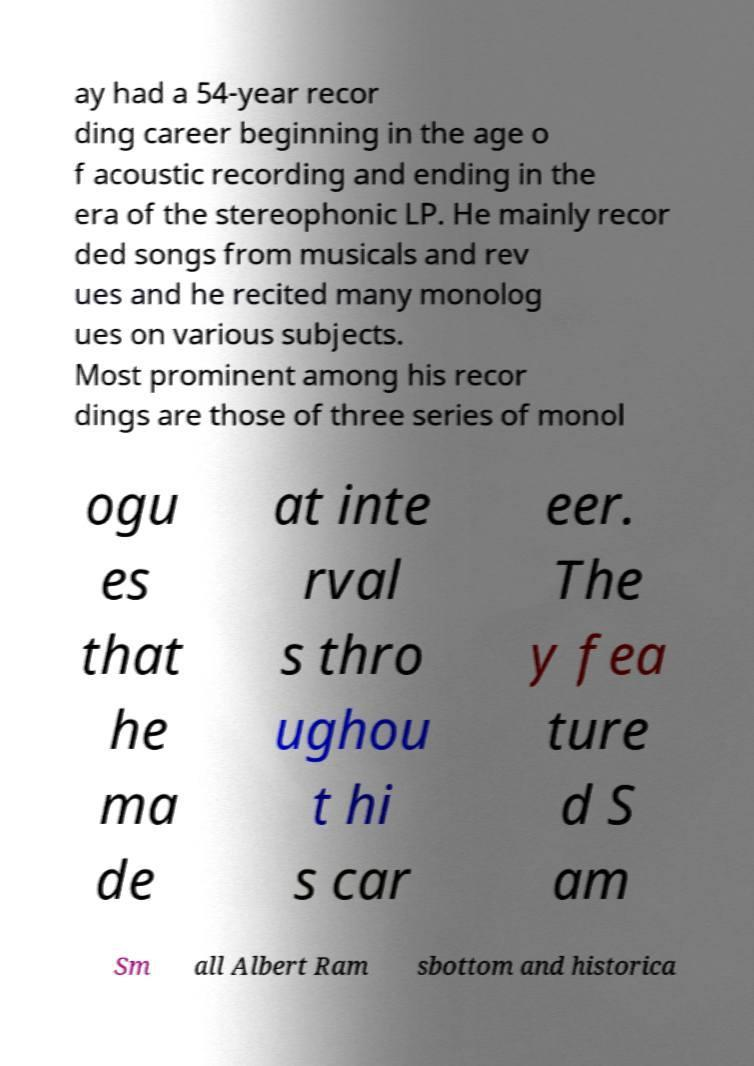For documentation purposes, I need the text within this image transcribed. Could you provide that? ay had a 54-year recor ding career beginning in the age o f acoustic recording and ending in the era of the stereophonic LP. He mainly recor ded songs from musicals and rev ues and he recited many monolog ues on various subjects. Most prominent among his recor dings are those of three series of monol ogu es that he ma de at inte rval s thro ughou t hi s car eer. The y fea ture d S am Sm all Albert Ram sbottom and historica 